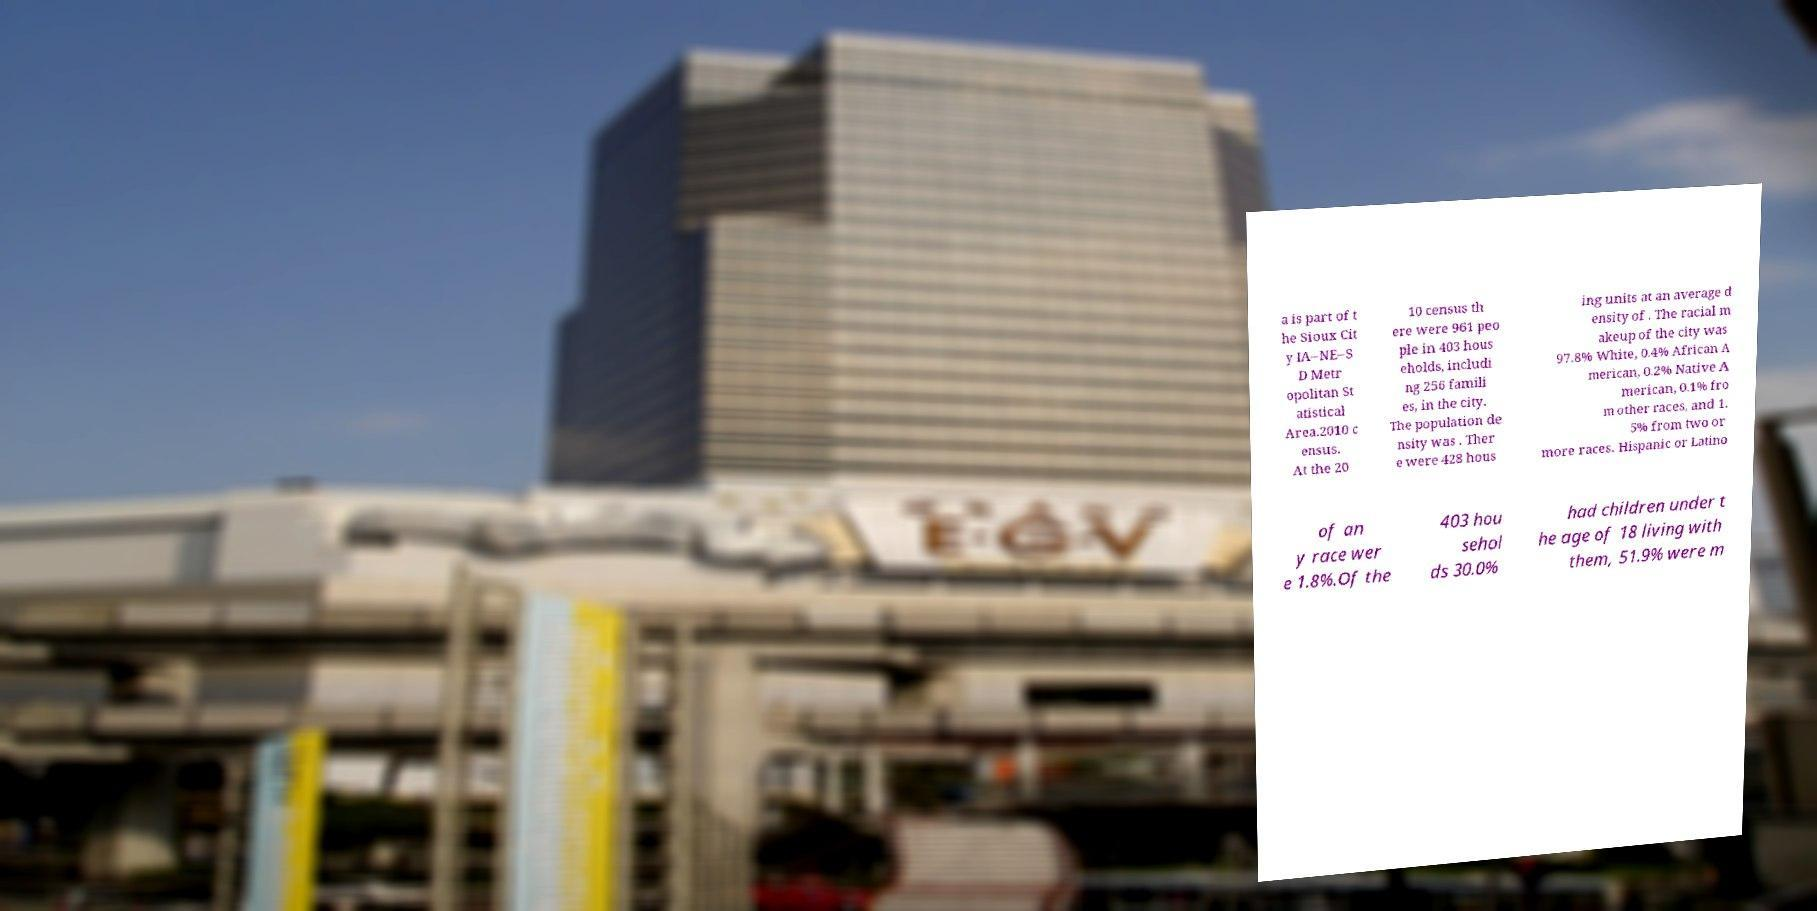Can you accurately transcribe the text from the provided image for me? a is part of t he Sioux Cit y IA–NE–S D Metr opolitan St atistical Area.2010 c ensus. At the 20 10 census th ere were 961 peo ple in 403 hous eholds, includi ng 256 famili es, in the city. The population de nsity was . Ther e were 428 hous ing units at an average d ensity of . The racial m akeup of the city was 97.8% White, 0.4% African A merican, 0.2% Native A merican, 0.1% fro m other races, and 1. 5% from two or more races. Hispanic or Latino of an y race wer e 1.8%.Of the 403 hou sehol ds 30.0% had children under t he age of 18 living with them, 51.9% were m 